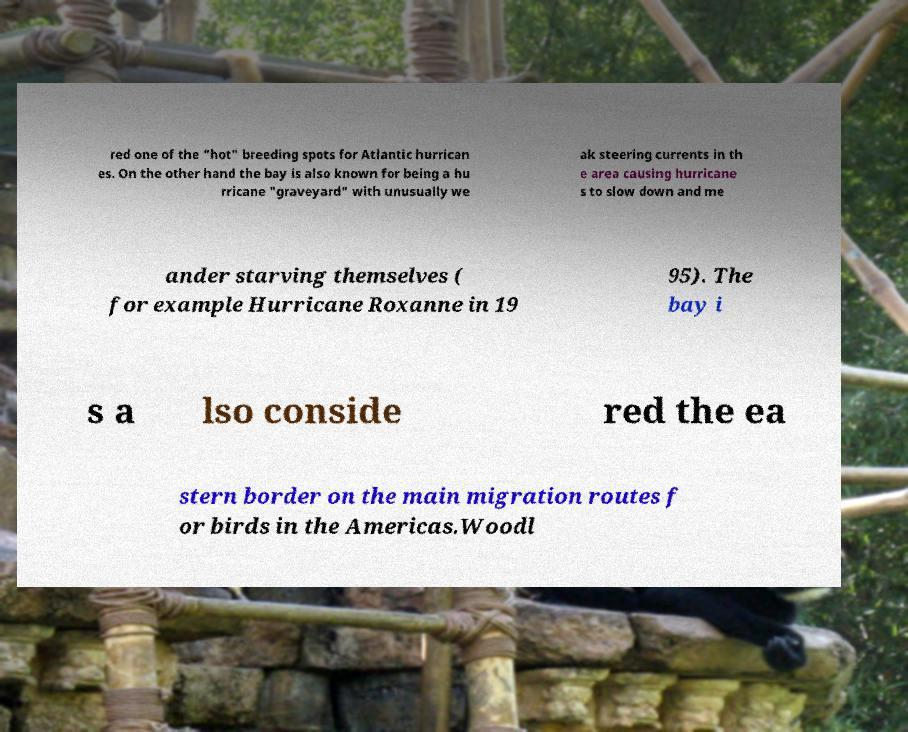For documentation purposes, I need the text within this image transcribed. Could you provide that? red one of the "hot" breeding spots for Atlantic hurrican es. On the other hand the bay is also known for being a hu rricane "graveyard" with unusually we ak steering currents in th e area causing hurricane s to slow down and me ander starving themselves ( for example Hurricane Roxanne in 19 95). The bay i s a lso conside red the ea stern border on the main migration routes f or birds in the Americas.Woodl 